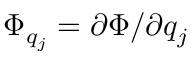Convert formula to latex. <formula><loc_0><loc_0><loc_500><loc_500>\Phi _ { q _ { j } } = \partial \Phi / \partial q _ { j }</formula> 